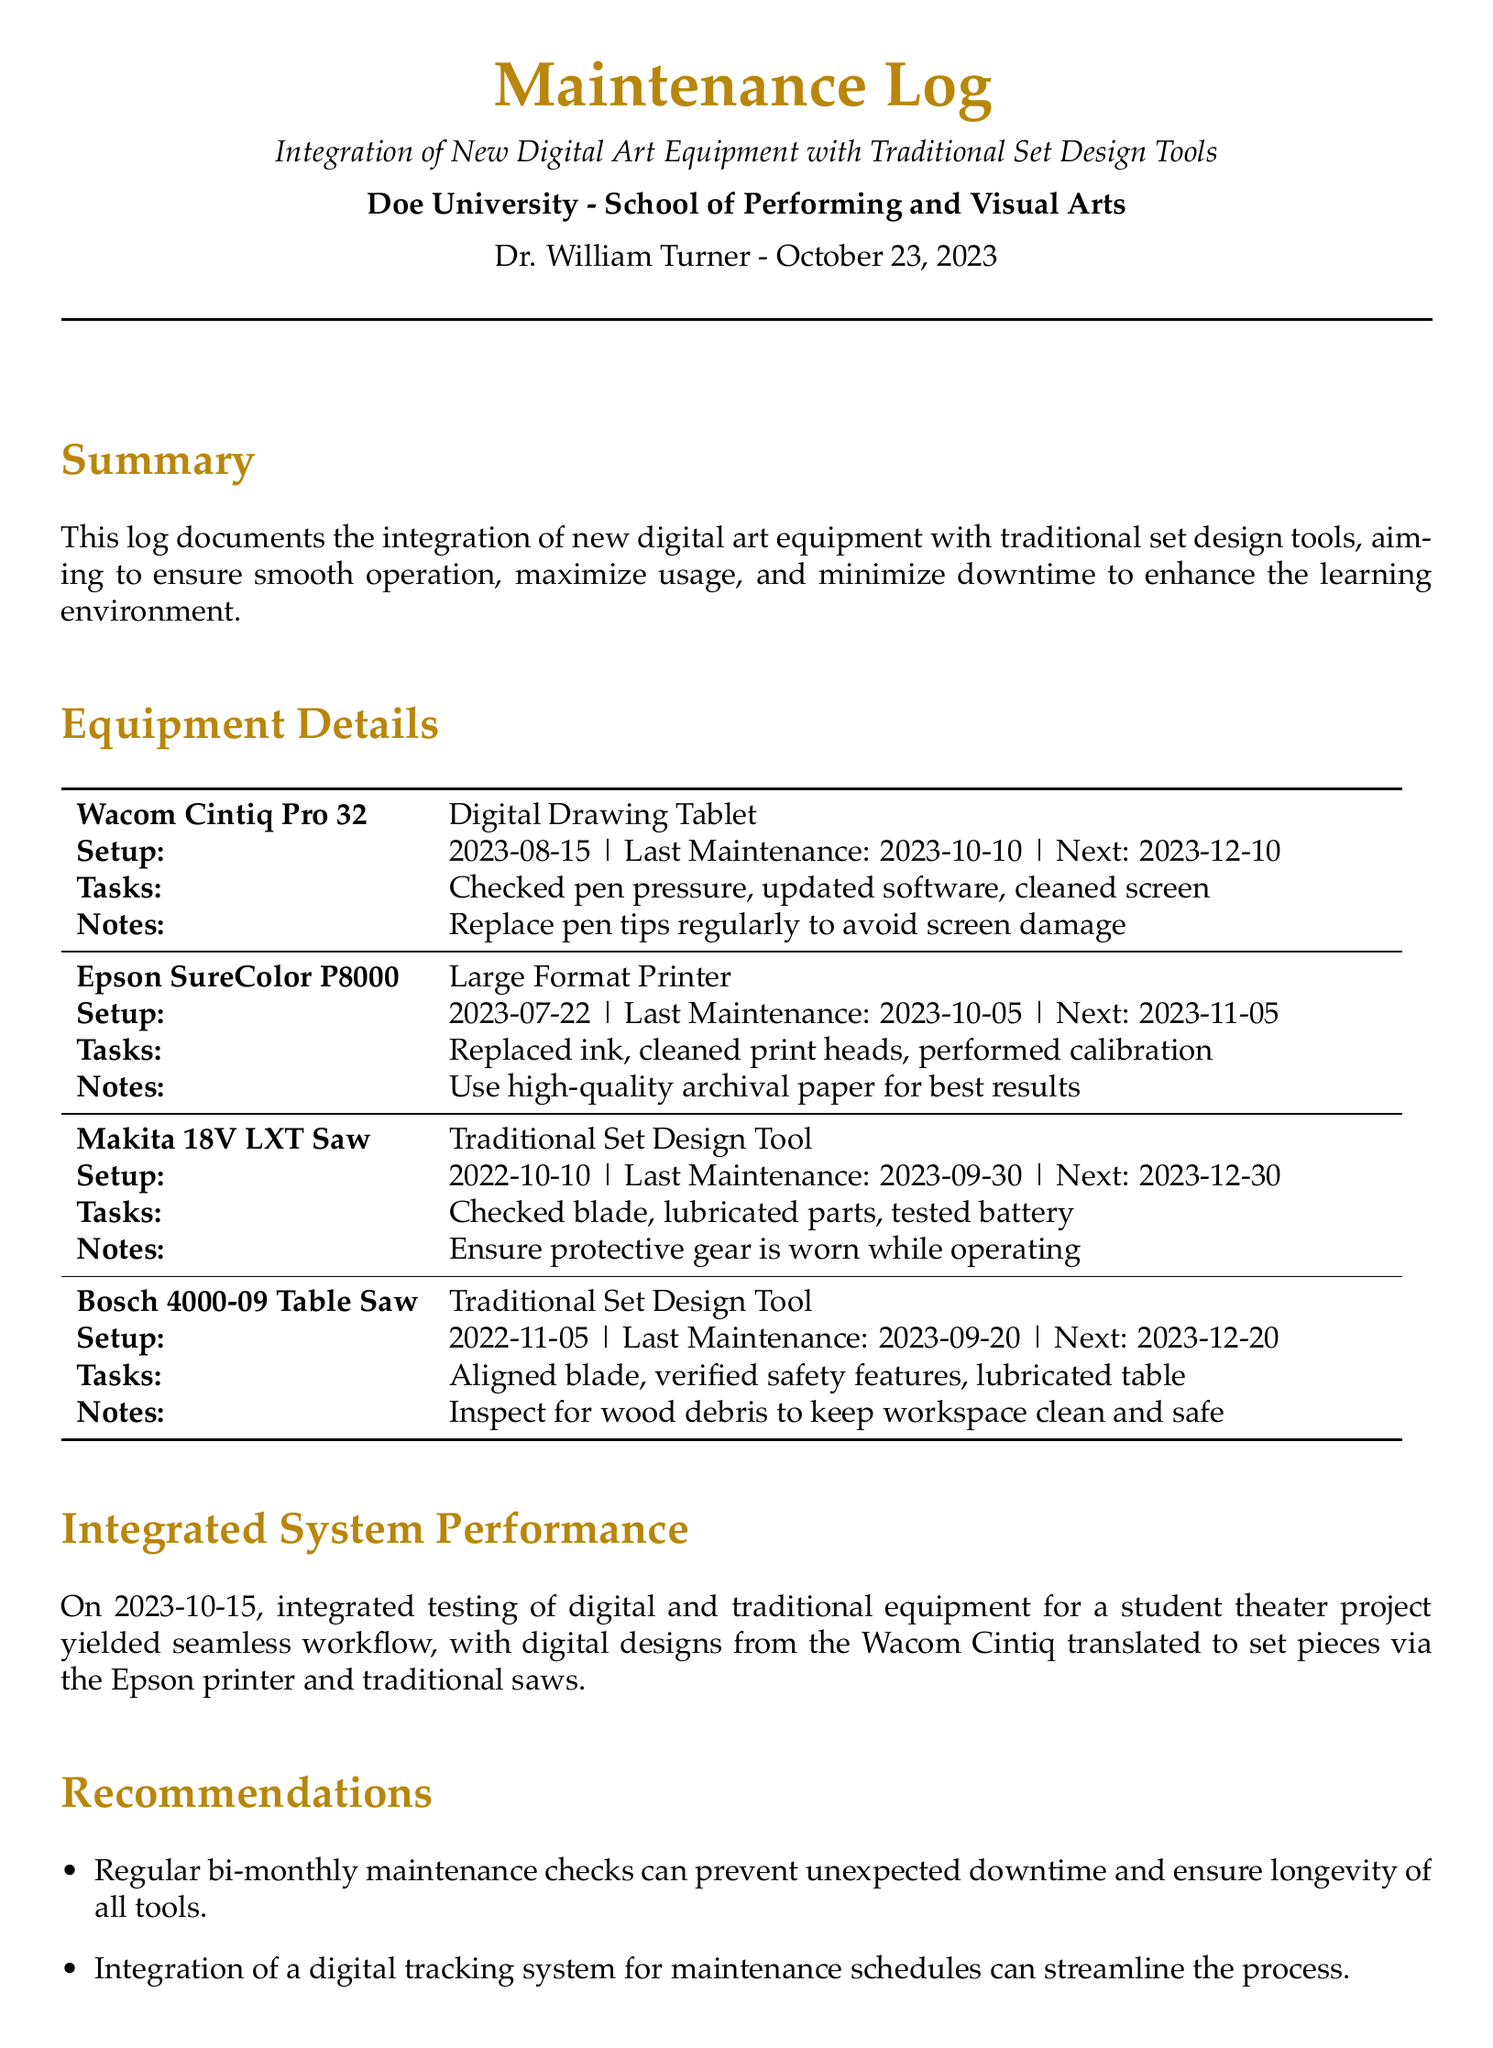what is the setup date for the Wacom Cintiq Pro 32? The setup date for the Wacom Cintiq Pro 32 is mentioned in the equipment details section as 2023-08-15.
Answer: 2023-08-15 when was the last maintenance for the Epson SureColor P8000? The last maintenance date for the Epson SureColor P8000 is detailed in the maintenance log as 2023-10-05.
Answer: 2023-10-05 what are the maintenance tasks for the Makita 18V LXT Saw? The maintenance tasks listed for the Makita 18V LXT Saw include checked blade, lubricated parts, and tested battery.
Answer: Checked blade, lubricated parts, tested battery how often should maintenance checks be conducted according to recommendations? The recommendations section specifies that regular bi-monthly maintenance checks should be conducted to prevent unexpected downtime.
Answer: Bi-monthly what benefits does the integration of digital and traditional tools provide? The conclusion states that the integration enhances students' creative capabilities by marrying innovation with craftsmanship.
Answer: Creative capabilities when was the integrated testing of equipment conducted? The testing date for the integrated system performance is clearly stated as 2023-10-15.
Answer: 2023-10-15 